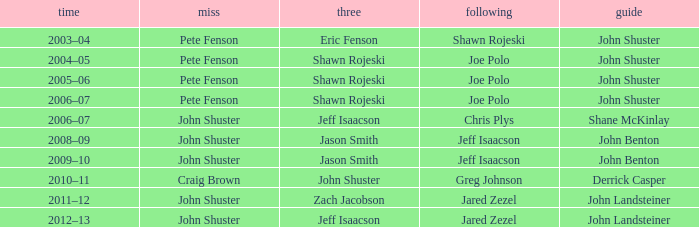Who was second when Shane McKinlay was the lead? Chris Plys. 